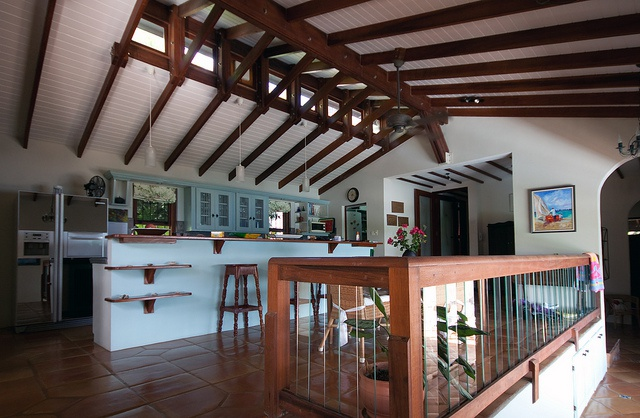Describe the objects in this image and their specific colors. I can see refrigerator in gray and black tones, potted plant in gray, black, and maroon tones, chair in gray, black, and maroon tones, potted plant in gray, black, maroon, and darkgray tones, and boat in gray, darkgray, and brown tones in this image. 